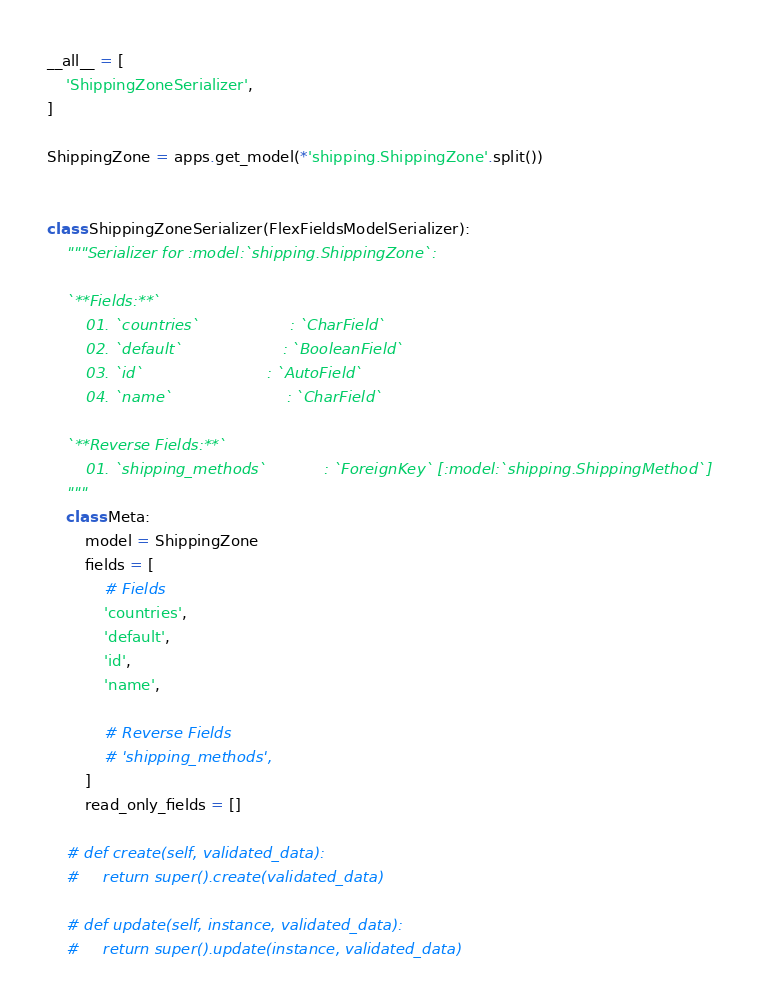Convert code to text. <code><loc_0><loc_0><loc_500><loc_500><_Python_>__all__ = [
    'ShippingZoneSerializer',
]

ShippingZone = apps.get_model(*'shipping.ShippingZone'.split())


class ShippingZoneSerializer(FlexFieldsModelSerializer):
    """Serializer for :model:`shipping.ShippingZone`:

    `**Fields:**`
        01. `countries`                   : `CharField`
        02. `default`                     : `BooleanField`
        03. `id`                          : `AutoField`
        04. `name`                        : `CharField`

    `**Reverse Fields:**`
        01. `shipping_methods`            : `ForeignKey` [:model:`shipping.ShippingMethod`]
    """
    class Meta:
        model = ShippingZone
        fields = [
            # Fields
            'countries',
            'default',
            'id',
            'name',

            # Reverse Fields
            # 'shipping_methods',
        ]
        read_only_fields = []

    # def create(self, validated_data):
    #     return super().create(validated_data)

    # def update(self, instance, validated_data):
    #     return super().update(instance, validated_data)
</code> 